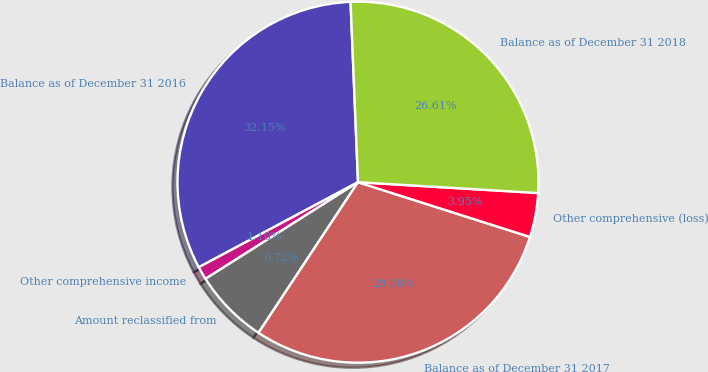<chart> <loc_0><loc_0><loc_500><loc_500><pie_chart><fcel>Balance as of December 31 2016<fcel>Other comprehensive income<fcel>Amount reclassified from<fcel>Balance as of December 31 2017<fcel>Other comprehensive (loss)<fcel>Balance as of December 31 2018<nl><fcel>32.16%<fcel>1.18%<fcel>6.72%<fcel>29.39%<fcel>3.95%<fcel>26.62%<nl></chart> 